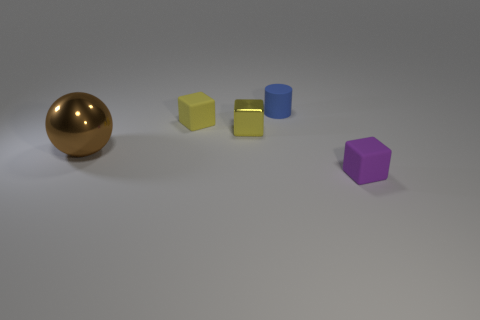Is there any other thing that is the same size as the brown object?
Your answer should be compact. No. Are there more tiny metal objects in front of the small yellow metal cube than small purple matte things to the left of the small rubber cylinder?
Your answer should be very brief. No. There is a matte cube that is the same color as the metal block; what size is it?
Provide a short and direct response. Small. What color is the big metal object?
Provide a short and direct response. Brown. The rubber object that is both behind the metal ball and right of the yellow metal block is what color?
Your answer should be compact. Blue. There is a tiny object behind the tiny rubber cube to the left of the tiny rubber object that is in front of the brown metal sphere; what is its color?
Provide a short and direct response. Blue. There is a matte cylinder that is the same size as the yellow shiny block; what is its color?
Keep it short and to the point. Blue. There is a small blue object on the right side of the yellow thing in front of the small block to the left of the yellow shiny object; what shape is it?
Offer a terse response. Cylinder. There is a thing that is the same color as the shiny block; what is its shape?
Your response must be concise. Cube. What number of objects are either purple blocks or matte things right of the blue rubber object?
Ensure brevity in your answer.  1. 